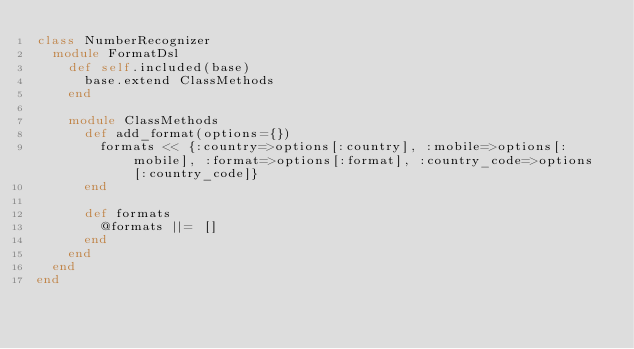Convert code to text. <code><loc_0><loc_0><loc_500><loc_500><_Ruby_>class NumberRecognizer
  module FormatDsl
    def self.included(base)
      base.extend ClassMethods
    end

    module ClassMethods
      def add_format(options={})
        formats << {:country=>options[:country], :mobile=>options[:mobile], :format=>options[:format], :country_code=>options[:country_code]}
      end

      def formats
        @formats ||= []
      end
    end
  end
end
</code> 